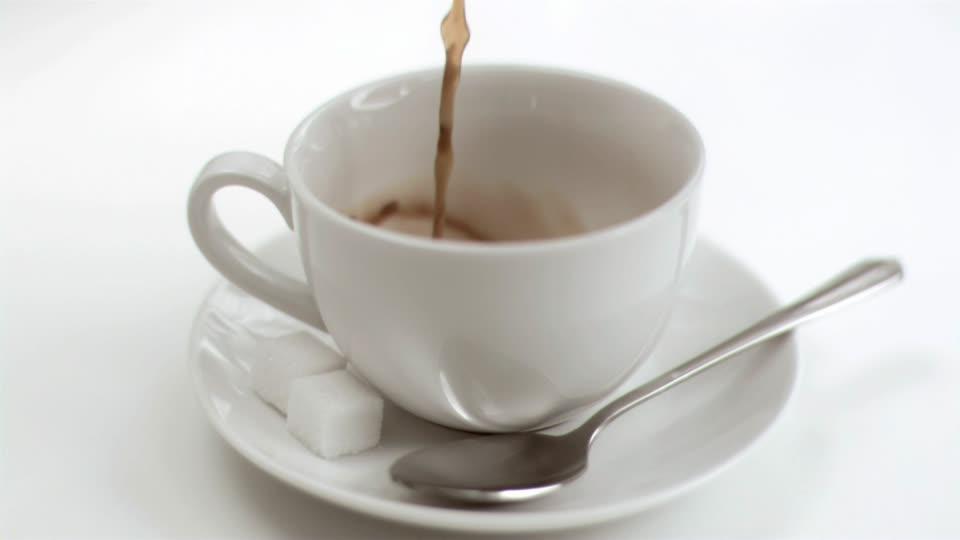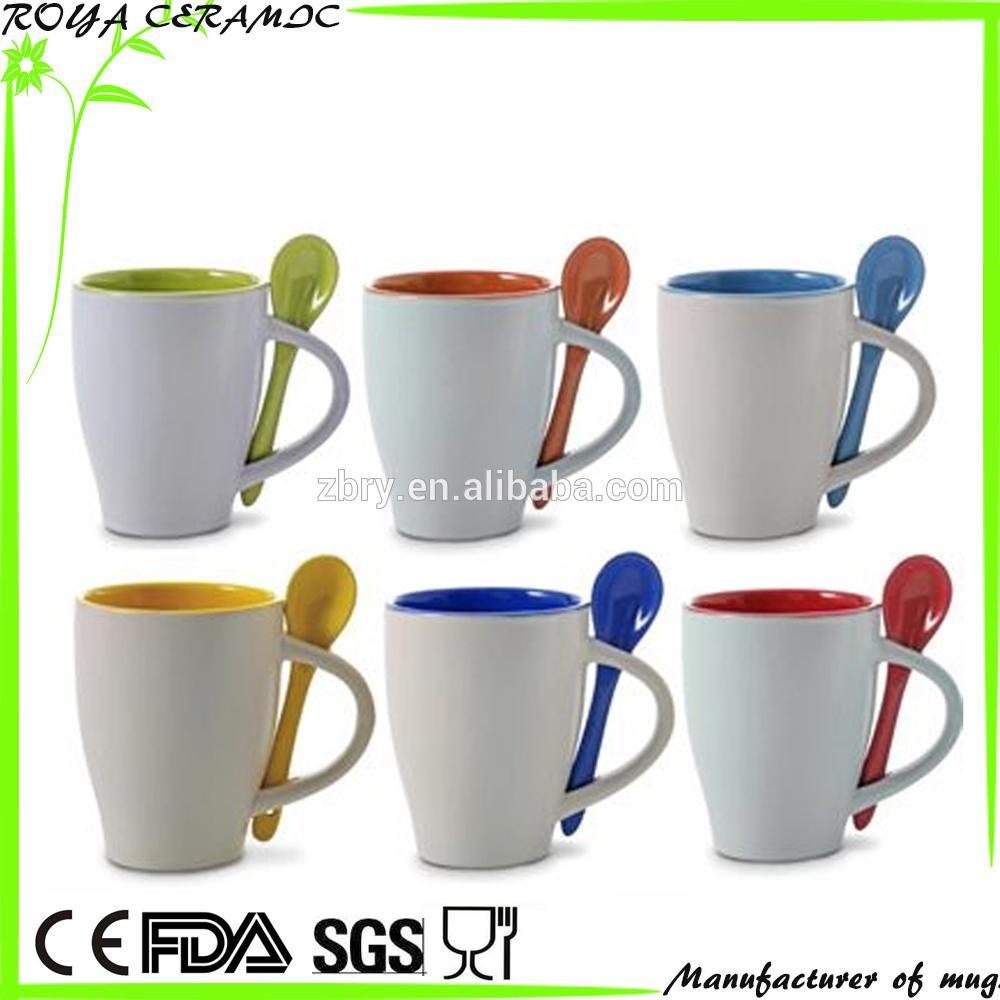The first image is the image on the left, the second image is the image on the right. Considering the images on both sides, is "There is at least one orange spoon in the image on the right." valid? Answer yes or no. Yes. 